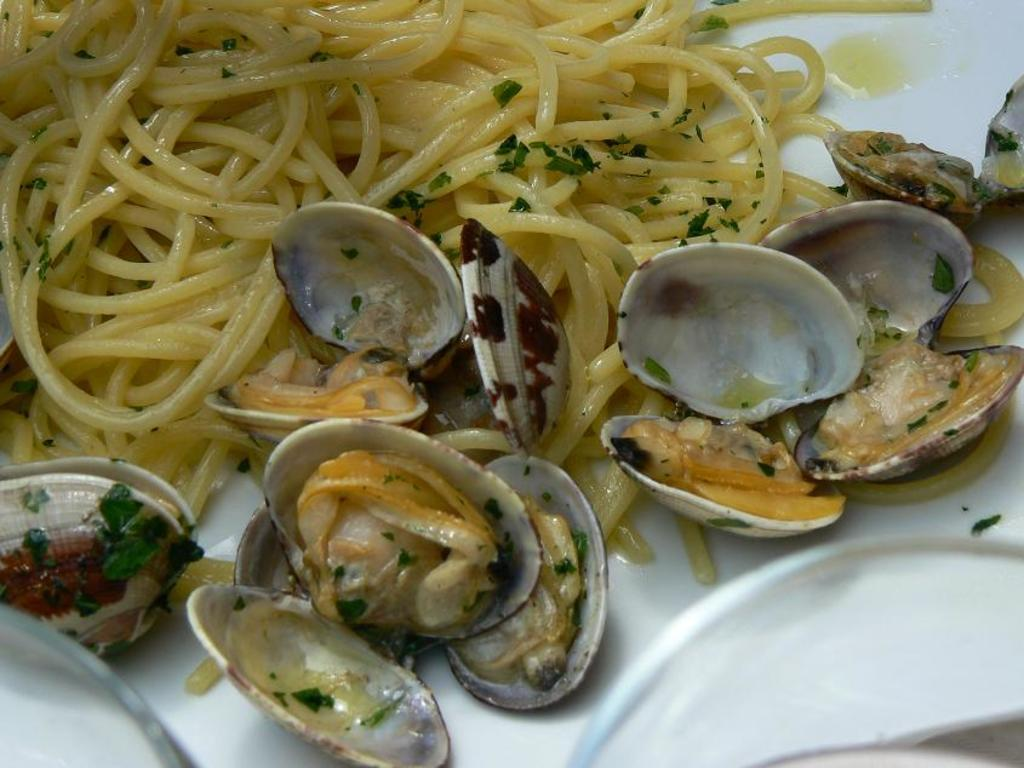What is located in the center of the image? There is a plate in the center of the image. What is on the plate? The plate contains noodles. Are there any additional items in the plate? Yes, there are shells in the plate. What is the interest rate on the loan mentioned in the image? There is no mention of a loan or interest rate in the image; it features a plate with noodles and shells. 